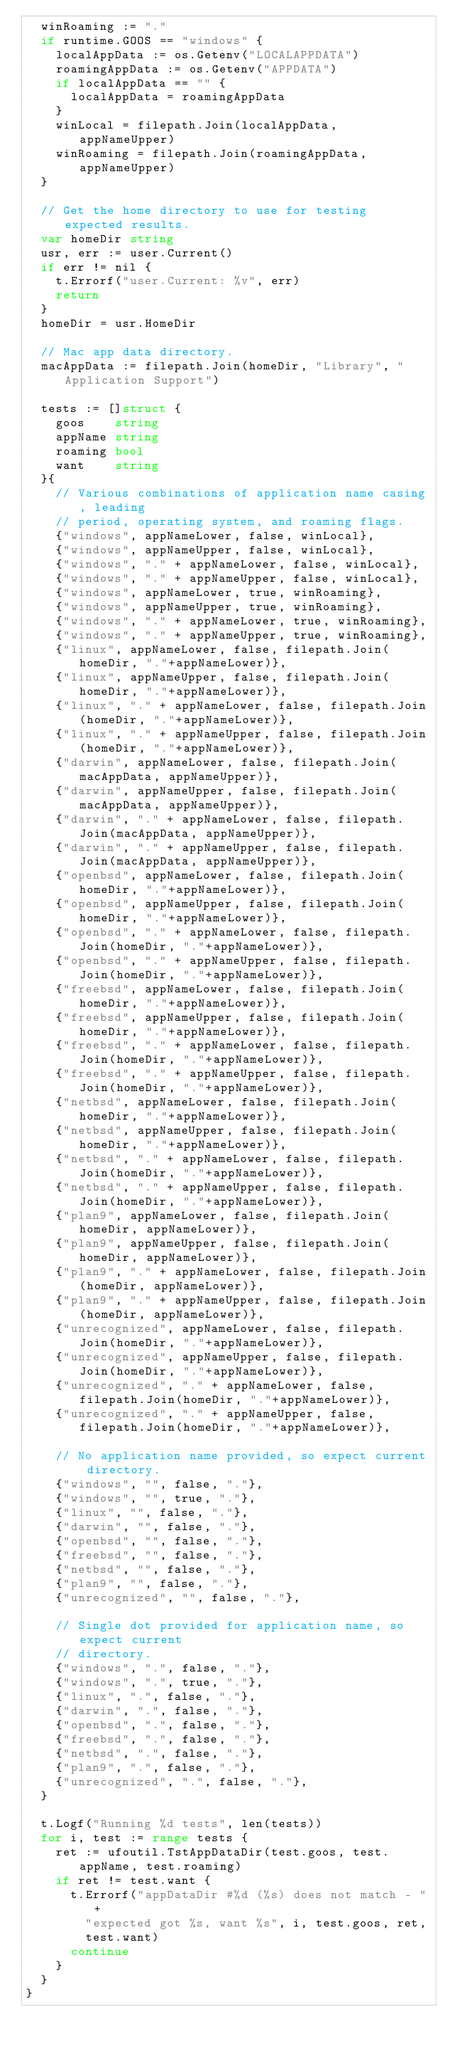Convert code to text. <code><loc_0><loc_0><loc_500><loc_500><_Go_>	winRoaming := "."
	if runtime.GOOS == "windows" {
		localAppData := os.Getenv("LOCALAPPDATA")
		roamingAppData := os.Getenv("APPDATA")
		if localAppData == "" {
			localAppData = roamingAppData
		}
		winLocal = filepath.Join(localAppData, appNameUpper)
		winRoaming = filepath.Join(roamingAppData, appNameUpper)
	}

	// Get the home directory to use for testing expected results.
	var homeDir string
	usr, err := user.Current()
	if err != nil {
		t.Errorf("user.Current: %v", err)
		return
	}
	homeDir = usr.HomeDir

	// Mac app data directory.
	macAppData := filepath.Join(homeDir, "Library", "Application Support")

	tests := []struct {
		goos    string
		appName string
		roaming bool
		want    string
	}{
		// Various combinations of application name casing, leading
		// period, operating system, and roaming flags.
		{"windows", appNameLower, false, winLocal},
		{"windows", appNameUpper, false, winLocal},
		{"windows", "." + appNameLower, false, winLocal},
		{"windows", "." + appNameUpper, false, winLocal},
		{"windows", appNameLower, true, winRoaming},
		{"windows", appNameUpper, true, winRoaming},
		{"windows", "." + appNameLower, true, winRoaming},
		{"windows", "." + appNameUpper, true, winRoaming},
		{"linux", appNameLower, false, filepath.Join(homeDir, "."+appNameLower)},
		{"linux", appNameUpper, false, filepath.Join(homeDir, "."+appNameLower)},
		{"linux", "." + appNameLower, false, filepath.Join(homeDir, "."+appNameLower)},
		{"linux", "." + appNameUpper, false, filepath.Join(homeDir, "."+appNameLower)},
		{"darwin", appNameLower, false, filepath.Join(macAppData, appNameUpper)},
		{"darwin", appNameUpper, false, filepath.Join(macAppData, appNameUpper)},
		{"darwin", "." + appNameLower, false, filepath.Join(macAppData, appNameUpper)},
		{"darwin", "." + appNameUpper, false, filepath.Join(macAppData, appNameUpper)},
		{"openbsd", appNameLower, false, filepath.Join(homeDir, "."+appNameLower)},
		{"openbsd", appNameUpper, false, filepath.Join(homeDir, "."+appNameLower)},
		{"openbsd", "." + appNameLower, false, filepath.Join(homeDir, "."+appNameLower)},
		{"openbsd", "." + appNameUpper, false, filepath.Join(homeDir, "."+appNameLower)},
		{"freebsd", appNameLower, false, filepath.Join(homeDir, "."+appNameLower)},
		{"freebsd", appNameUpper, false, filepath.Join(homeDir, "."+appNameLower)},
		{"freebsd", "." + appNameLower, false, filepath.Join(homeDir, "."+appNameLower)},
		{"freebsd", "." + appNameUpper, false, filepath.Join(homeDir, "."+appNameLower)},
		{"netbsd", appNameLower, false, filepath.Join(homeDir, "."+appNameLower)},
		{"netbsd", appNameUpper, false, filepath.Join(homeDir, "."+appNameLower)},
		{"netbsd", "." + appNameLower, false, filepath.Join(homeDir, "."+appNameLower)},
		{"netbsd", "." + appNameUpper, false, filepath.Join(homeDir, "."+appNameLower)},
		{"plan9", appNameLower, false, filepath.Join(homeDir, appNameLower)},
		{"plan9", appNameUpper, false, filepath.Join(homeDir, appNameLower)},
		{"plan9", "." + appNameLower, false, filepath.Join(homeDir, appNameLower)},
		{"plan9", "." + appNameUpper, false, filepath.Join(homeDir, appNameLower)},
		{"unrecognized", appNameLower, false, filepath.Join(homeDir, "."+appNameLower)},
		{"unrecognized", appNameUpper, false, filepath.Join(homeDir, "."+appNameLower)},
		{"unrecognized", "." + appNameLower, false, filepath.Join(homeDir, "."+appNameLower)},
		{"unrecognized", "." + appNameUpper, false, filepath.Join(homeDir, "."+appNameLower)},

		// No application name provided, so expect current directory.
		{"windows", "", false, "."},
		{"windows", "", true, "."},
		{"linux", "", false, "."},
		{"darwin", "", false, "."},
		{"openbsd", "", false, "."},
		{"freebsd", "", false, "."},
		{"netbsd", "", false, "."},
		{"plan9", "", false, "."},
		{"unrecognized", "", false, "."},

		// Single dot provided for application name, so expect current
		// directory.
		{"windows", ".", false, "."},
		{"windows", ".", true, "."},
		{"linux", ".", false, "."},
		{"darwin", ".", false, "."},
		{"openbsd", ".", false, "."},
		{"freebsd", ".", false, "."},
		{"netbsd", ".", false, "."},
		{"plan9", ".", false, "."},
		{"unrecognized", ".", false, "."},
	}

	t.Logf("Running %d tests", len(tests))
	for i, test := range tests {
		ret := ufoutil.TstAppDataDir(test.goos, test.appName, test.roaming)
		if ret != test.want {
			t.Errorf("appDataDir #%d (%s) does not match - "+
				"expected got %s, want %s", i, test.goos, ret,
				test.want)
			continue
		}
	}
}
</code> 